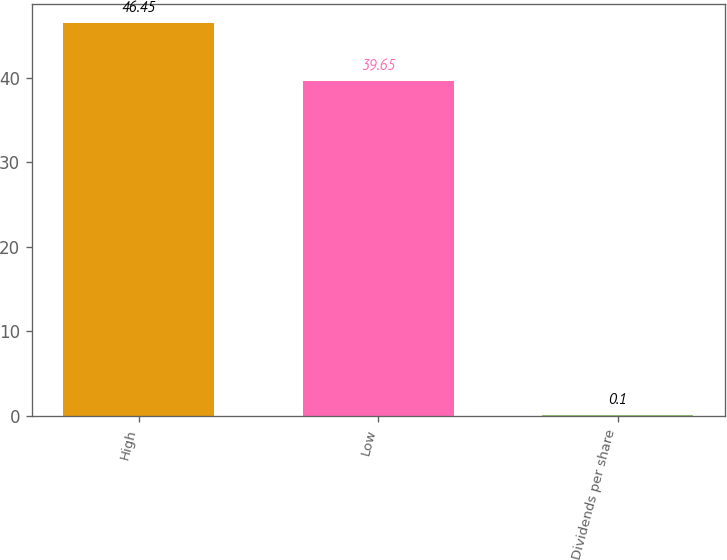<chart> <loc_0><loc_0><loc_500><loc_500><bar_chart><fcel>High<fcel>Low<fcel>Dividends per share<nl><fcel>46.45<fcel>39.65<fcel>0.1<nl></chart> 